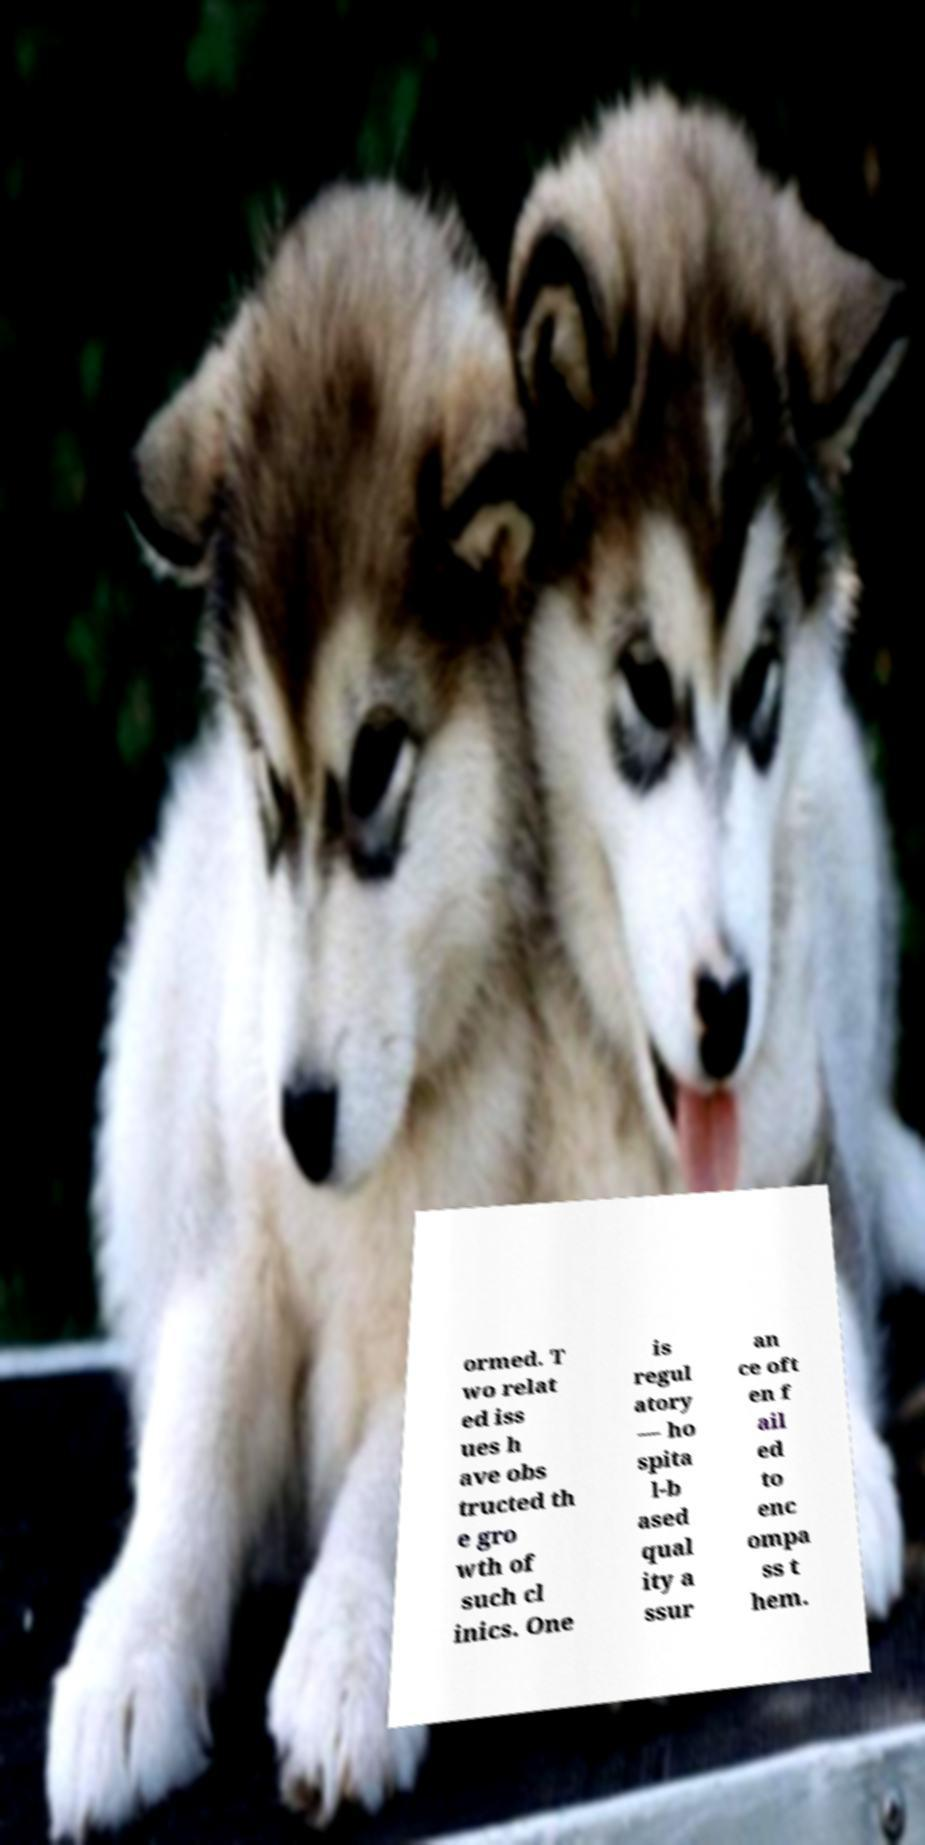Can you read and provide the text displayed in the image?This photo seems to have some interesting text. Can you extract and type it out for me? ormed. T wo relat ed iss ues h ave obs tructed th e gro wth of such cl inics. One is regul atory — ho spita l-b ased qual ity a ssur an ce oft en f ail ed to enc ompa ss t hem. 